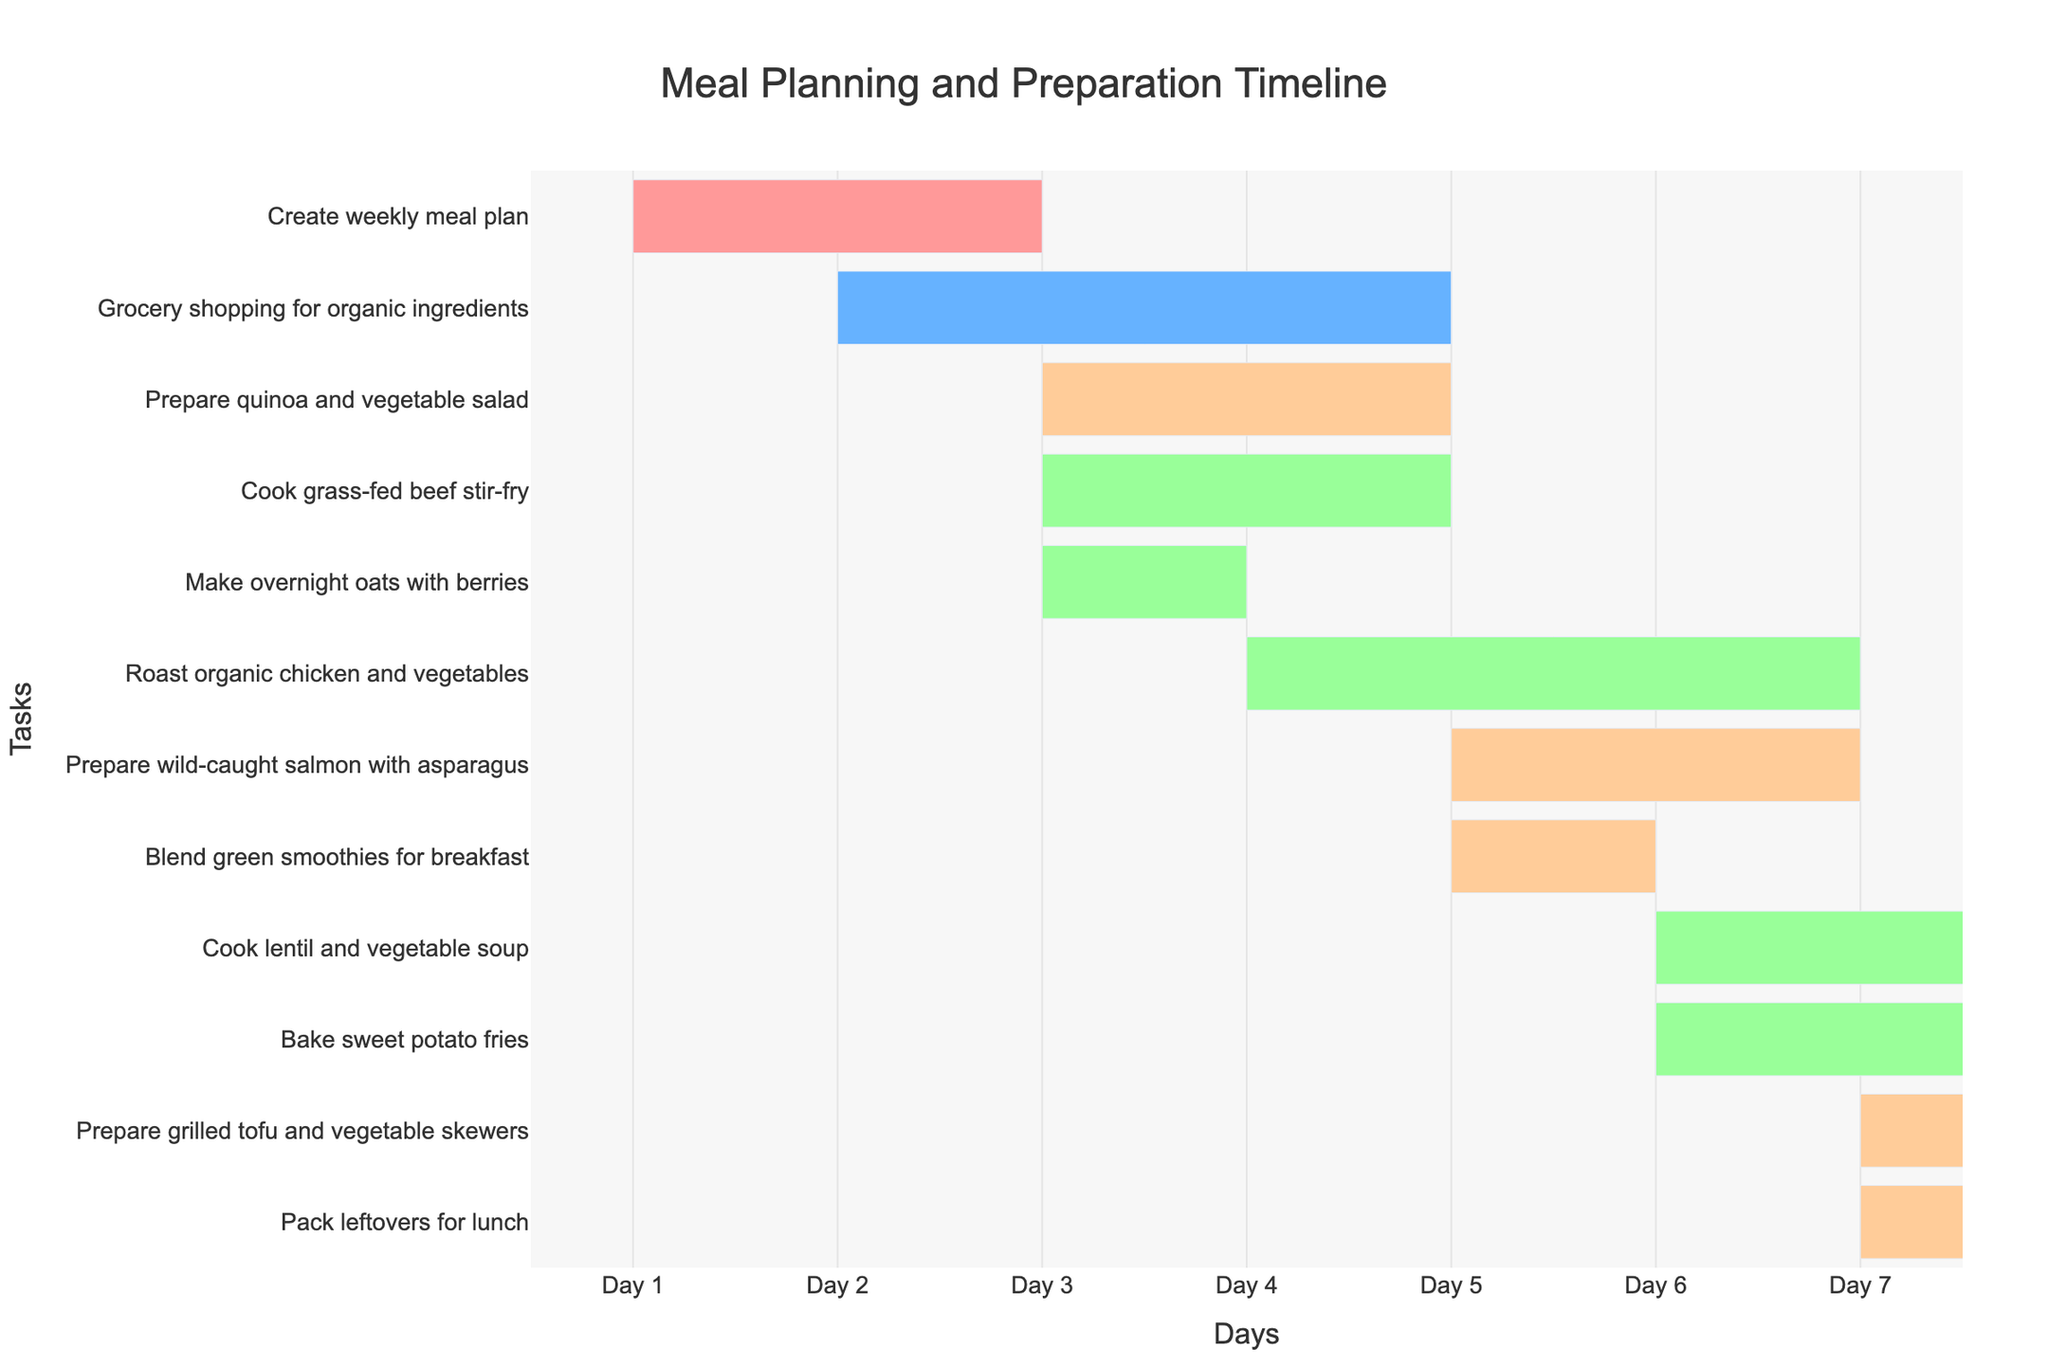What is the title of the Gantt chart? The title of the Gantt chart is located at the top of the figure in large, bold font.
Answer: "Meal Planning and Preparation Timeline" On which day does 'Create weekly meal plan' start? This can be seen from the first task in the Y-axis and its corresponding position on the X-axis tick marks.
Answer: Day 1 Which task has the shortest duration? By comparing the length of the bars, we can see that the task with the shortest horizontal bar has the shortest duration. The task 'Make overnight oats with berries' has a duration of 1 day.
Answer: 'Make overnight oats with berries' How many tasks are scheduled to start on Day 3? Check the X-axis's position for Day 3 and count the number of tasks that begin at this position. Three tasks are starting on Day 3.
Answer: 3 Which tasks are categorized as 'Planning'? To find this, look at the color legend and identify the tasks with the corresponding color for 'Planning'. Only one task has this color, which is 'Create weekly meal plan'.
Answer: 'Create weekly meal plan' What is the total duration for all tasks classified under 'Cooking'? First, identify tasks under 'Cooking' based on their color, then sum up their durations: Grass-fed beef stir-fry (2), Roast organic chicken and vegetables (3), Wild-caught salmon with asparagus (2), Lentil and vegetable soup (3), and Sweet potato fries (2). 2 + 3 + 2 + 3 + 2 = 12 days.
Answer: 12 days Which task ends on Day 5? Check the task that starts and has a duration such that it ends on Day 5 ('start day + duration = end day'). 'Roast organic chicken and vegetables' starts on Day 4 and has a duration of 3 days, thus it ends on Day 4 + 3 = Day 5.
Answer: 'Roast organic chicken and vegetables' Are there any tasks that overlap with 'Bake sweet potato fries'? To determine this, check the starting and ending points of 'Bake sweet potato fries' alongside other tasks. It starts on Day 6 and ends on Day 8, overlapping with 'Cook lentil and vegetable soup' which also starts on Day 6 and ends on Day 9.
Answer: Yes, 'Cook lentil and vegetable soup' Which task takes more time, 'Grocery shopping for organic ingredients' or 'Roast organic chicken and vegetables'? Compare the durations of both tasks: 'Grocery shopping for organic ingredients' has a duration of 3 days and 'Roast organic chicken and vegetables' also has a duration of 3 days. Both tasks take the same amount of time.
Answer: Both take 3 days What is the last task in the Gantt chart? The last task can be identified at the bottom of the Y-axis. 'Pack leftovers for lunch' is the last task listed.
Answer: 'Pack leftovers for lunch' 